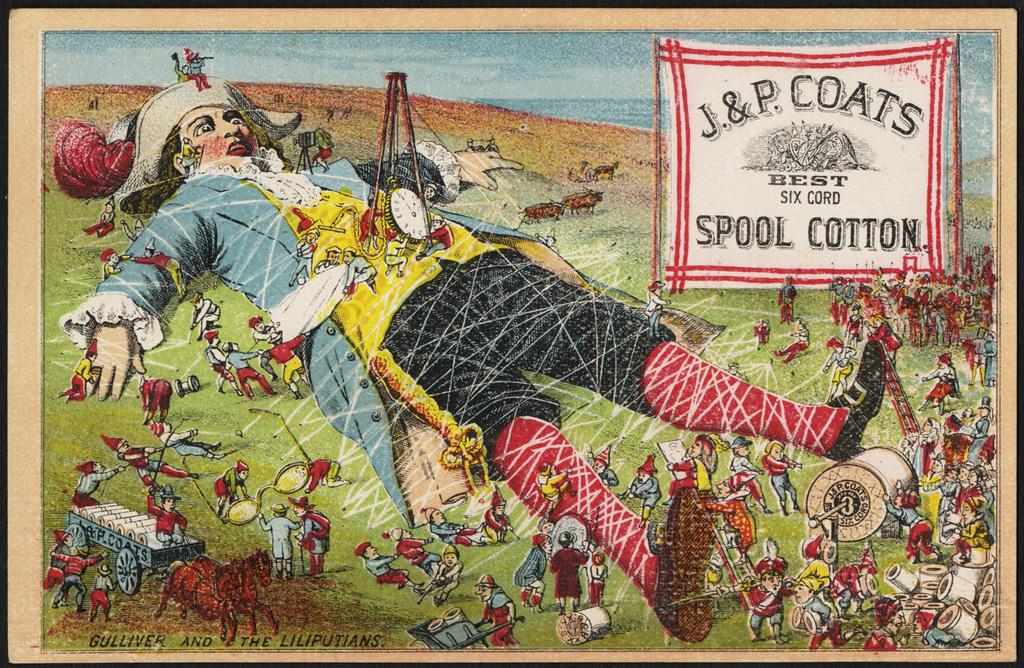What corporate group is this poster for?
Offer a terse response. J&p coats. 